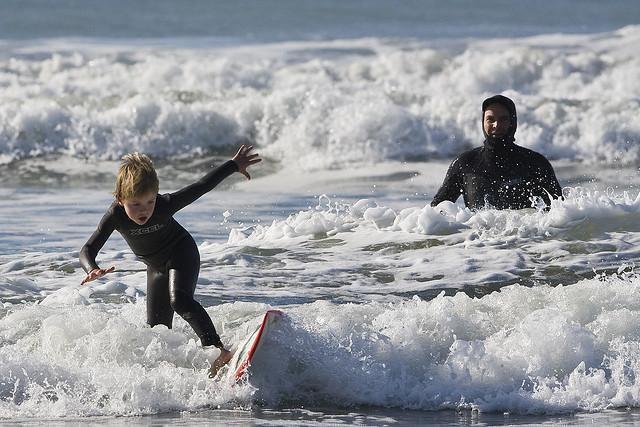Why are they wearing wetsuits?
Pick the correct solution from the four options below to address the question.
Options: For fun, cold water, easier finding, showing off. Cold water. 